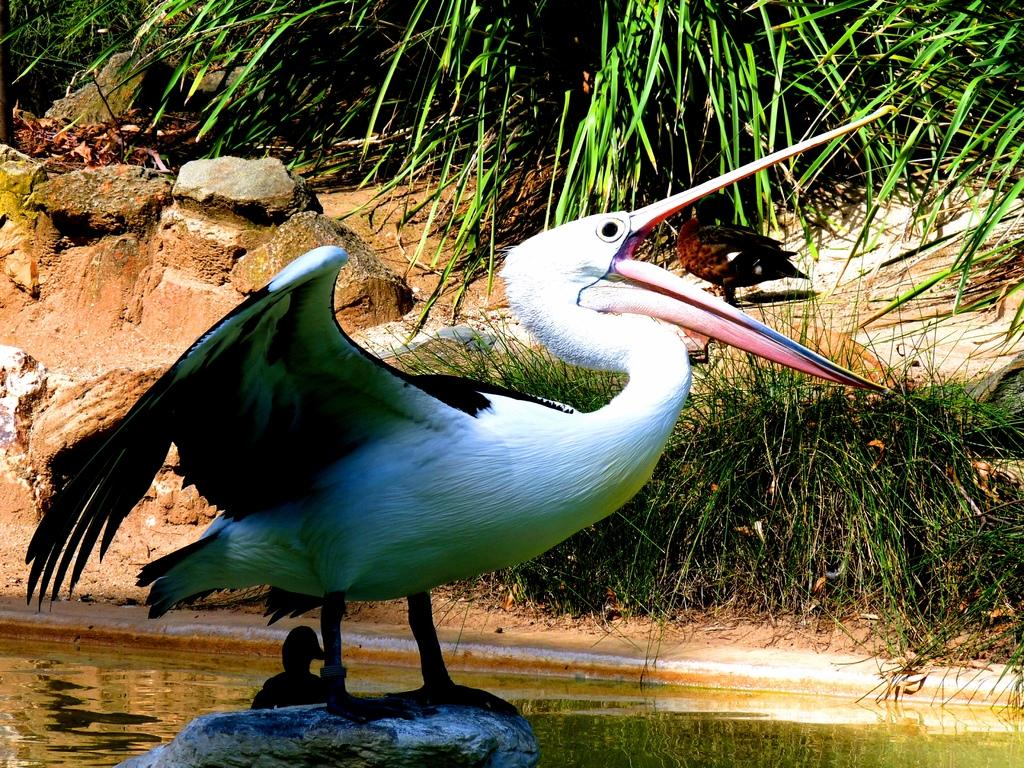What type of animal is in the image? There is a water bird in the image. Where is the water bird located? The water bird is present on a stone. What is the stone's location in the image? The stone is in the water. What is the ground like in the image? The ground is covered with grass and stones. Are there any plants visible in the image? Yes, plants are present on the ground. What type of frame is visible around the water bird in the image? There is no frame visible around the water bird in the image. What color is the cloth draped over the water bird in the image? There is no cloth draped over the water bird in the image. 